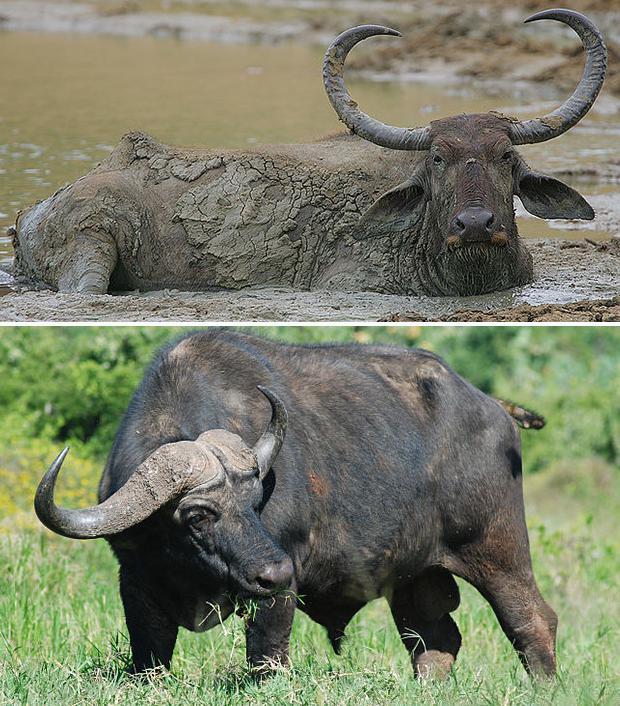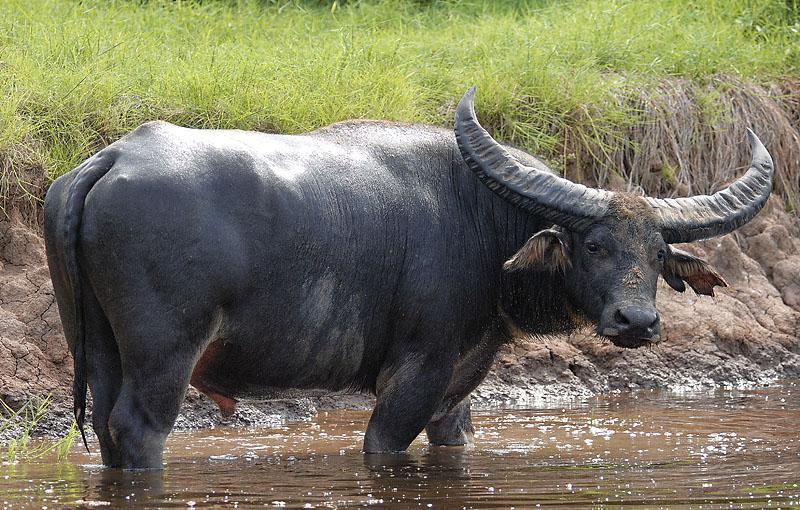The first image is the image on the left, the second image is the image on the right. Given the left and right images, does the statement "In one of the images, the wildebeest are chasing the lion." hold true? Answer yes or no. No. 